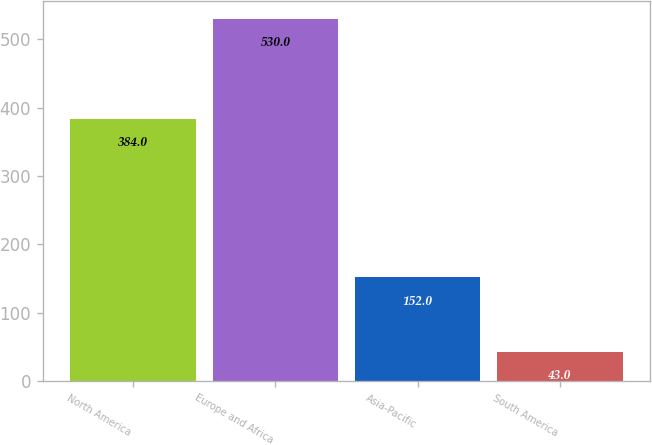Convert chart. <chart><loc_0><loc_0><loc_500><loc_500><bar_chart><fcel>North America<fcel>Europe and Africa<fcel>Asia-Pacific<fcel>South America<nl><fcel>384<fcel>530<fcel>152<fcel>43<nl></chart> 